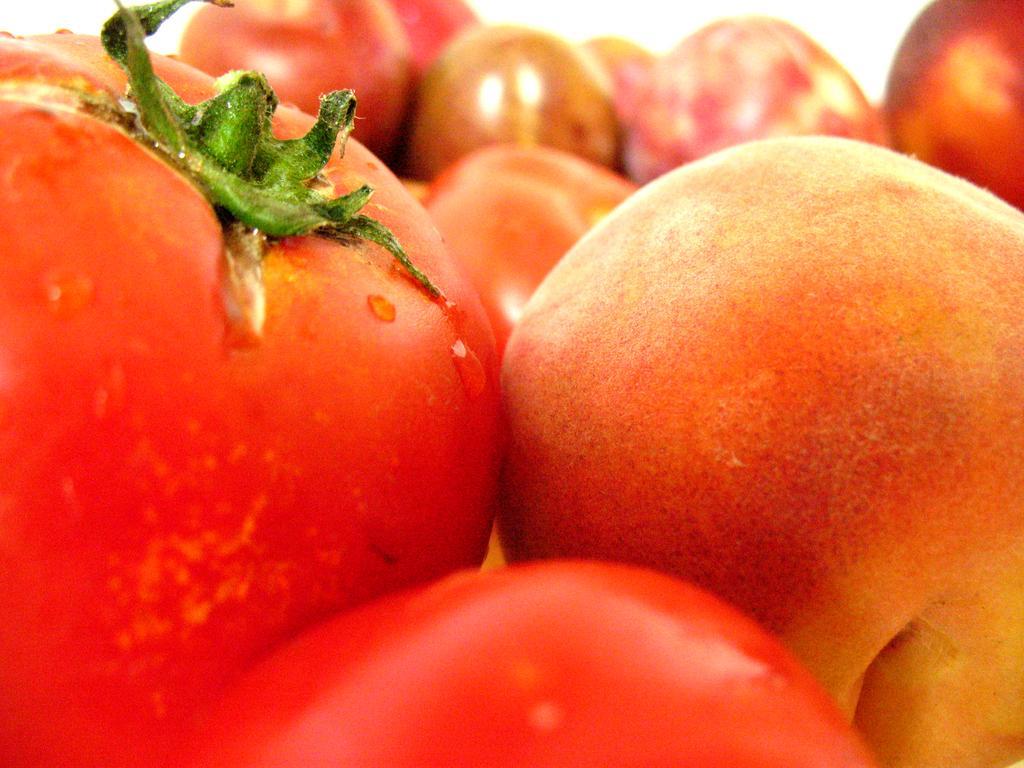Please provide a concise description of this image. In this image I can see red color tomatoes. 